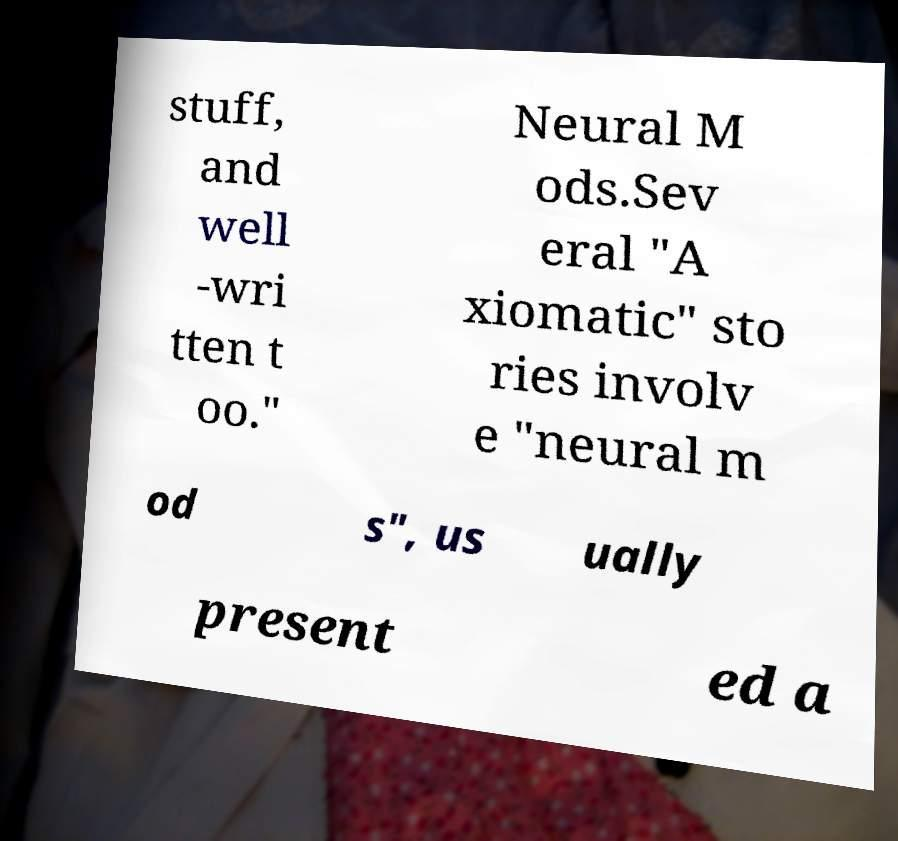I need the written content from this picture converted into text. Can you do that? stuff, and well -wri tten t oo." Neural M ods.Sev eral "A xiomatic" sto ries involv e "neural m od s", us ually present ed a 